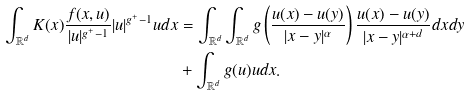Convert formula to latex. <formula><loc_0><loc_0><loc_500><loc_500>\int _ { \mathbb { R } ^ { d } } K ( x ) \frac { f ( x , u ) } { | u | ^ { g ^ { + } - 1 } } | u | ^ { g ^ { + } - 1 } u d x & = \int _ { \mathbb { R } ^ { d } } \int _ { \mathbb { R } ^ { d } } g \left ( \frac { u ( x ) - u ( y ) } { | x - y | ^ { \alpha } } \right ) \frac { u ( x ) - u ( y ) } { | x - y | ^ { \alpha + d } } d x d y \\ & + \int _ { \mathbb { R } ^ { d } } g ( u ) u d x .</formula> 